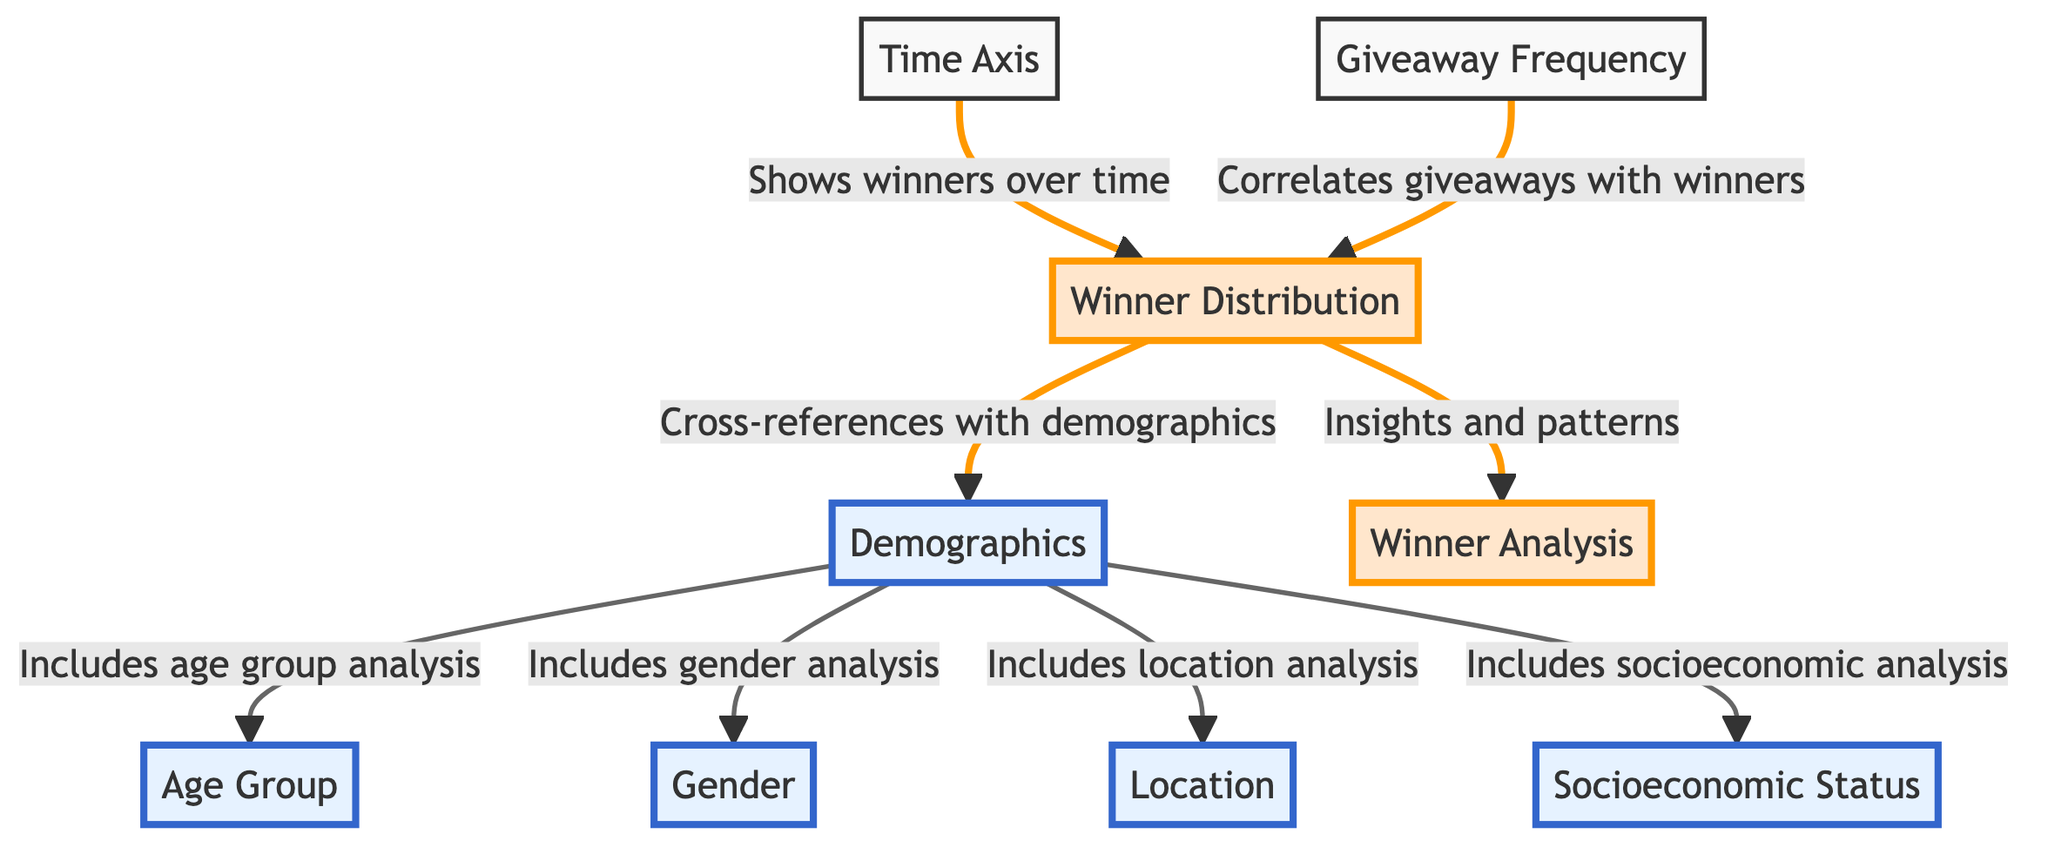What does the time axis show? The time axis indicates the progression of winners across different time periods, providing a temporal reference for winner distribution.
Answer: Winners over time How many main demographic analyses are conducted? There are four main demographic analyses presented in the diagram: age group, gender, location, and socioeconomic status. By counting these nodes, we can confirm their total count.
Answer: Four What is correlated with the winner distribution? The giveaway frequency is directly linked to the winner distribution, indicating that the frequency of giveaways impacts the number of winners awarded over time.
Answer: Giveaway frequency Which analyses are emphasized in the diagram? The diagram emphasizes the demographics analysis, including age group, gender, location, and socioeconomic status, highlighting their importance in understanding winner distribution.
Answer: Demographics, age group, gender, location, socioeconomic status What insights does the winner distribution lead to? The winner distribution provides insights and patterns related to how winners are selected and their demographics, which helps in understanding fairness in giveaways.
Answer: Insights and patterns 